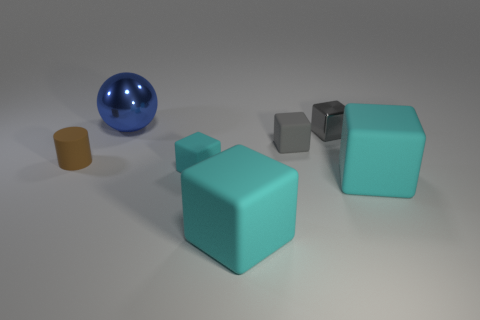Subtract all large blocks. How many blocks are left? 3 Add 1 blue cubes. How many objects exist? 8 Subtract all cyan spheres. How many gray blocks are left? 2 Subtract all gray cubes. How many cubes are left? 3 Subtract all cubes. How many objects are left? 2 Subtract 1 cubes. How many cubes are left? 4 Subtract 0 red blocks. How many objects are left? 7 Subtract all blue blocks. Subtract all green cylinders. How many blocks are left? 5 Subtract all brown cylinders. Subtract all balls. How many objects are left? 5 Add 4 tiny metallic objects. How many tiny metallic objects are left? 5 